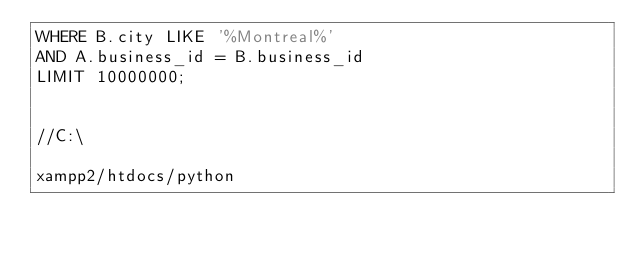Convert code to text. <code><loc_0><loc_0><loc_500><loc_500><_SQL_>WHERE B.city LIKE '%Montreal%' 
AND A.business_id = B.business_id
LIMIT 10000000;


//C:\

xampp2/htdocs/python
</code> 